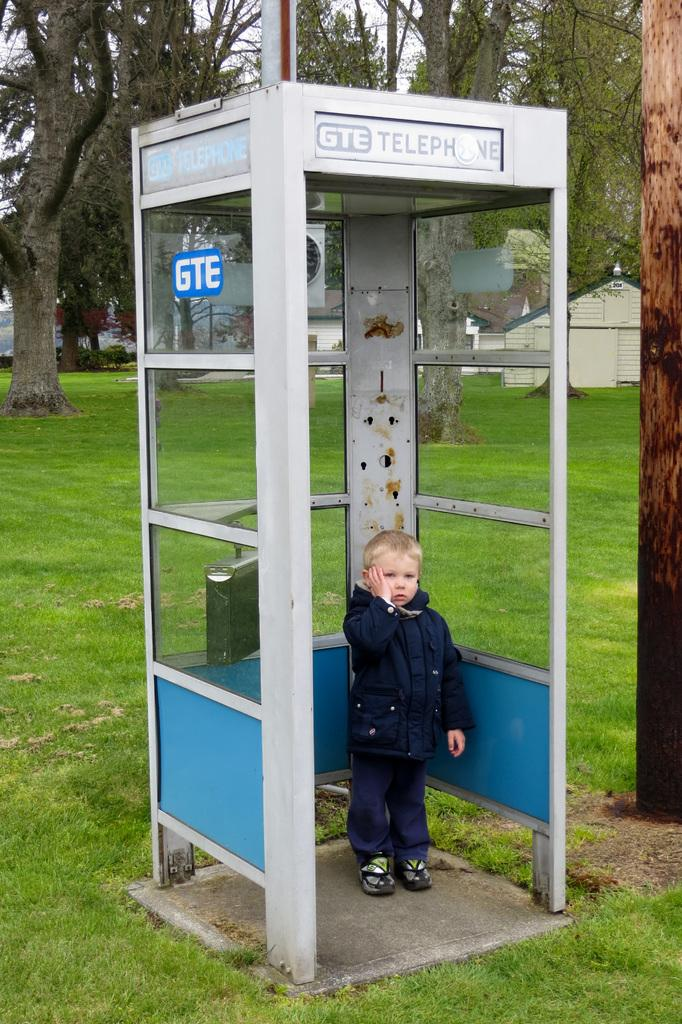What is the boy doing in the image? The boy is standing in a telephone booth. What type of surface is under the boy's feet? There is grass on the ground. What can be seen in the distance behind the boy? There are trees and buildings in the background. What type of food is the boy holding in the image? There is no food visible in the image; the boy is standing in a telephone booth. What kind of bag is the boy carrying in the image? There is no bag visible in the image; the boy is standing in a telephone booth. 